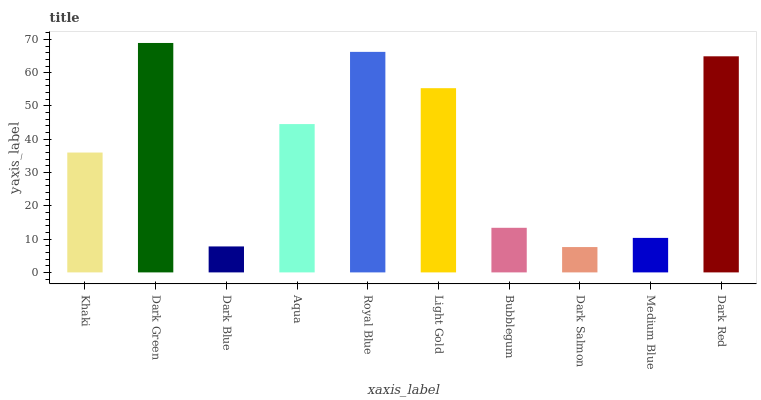Is Dark Salmon the minimum?
Answer yes or no. Yes. Is Dark Green the maximum?
Answer yes or no. Yes. Is Dark Blue the minimum?
Answer yes or no. No. Is Dark Blue the maximum?
Answer yes or no. No. Is Dark Green greater than Dark Blue?
Answer yes or no. Yes. Is Dark Blue less than Dark Green?
Answer yes or no. Yes. Is Dark Blue greater than Dark Green?
Answer yes or no. No. Is Dark Green less than Dark Blue?
Answer yes or no. No. Is Aqua the high median?
Answer yes or no. Yes. Is Khaki the low median?
Answer yes or no. Yes. Is Dark Blue the high median?
Answer yes or no. No. Is Dark Red the low median?
Answer yes or no. No. 